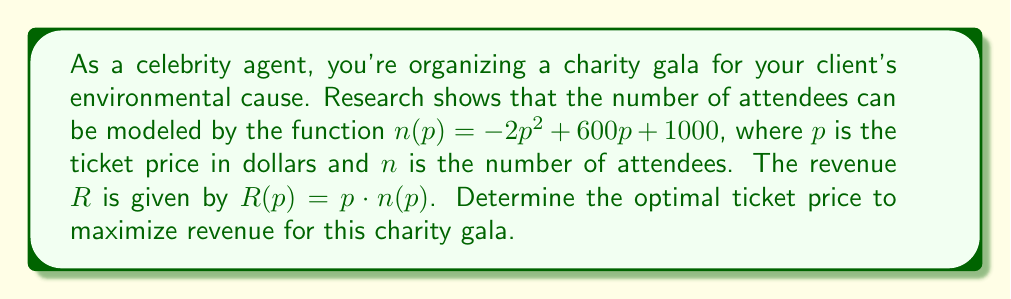Could you help me with this problem? To find the optimal ticket price, we need to follow these steps:

1) First, let's express the revenue function in terms of $p$:
   $R(p) = p \cdot n(p) = p(-2p^2 + 600p + 1000)$
   $R(p) = -2p^3 + 600p^2 + 1000p$

2) To find the maximum revenue, we need to find the critical points of this function. We do this by taking the derivative and setting it equal to zero:
   $R'(p) = -6p^2 + 1200p + 1000$
   $-6p^2 + 1200p + 1000 = 0$

3) This is a quadratic equation. We can solve it using the quadratic formula:
   $p = \frac{-b \pm \sqrt{b^2 - 4ac}}{2a}$

   Where $a = -6$, $b = 1200$, and $c = 1000$

4) Plugging in these values:
   $p = \frac{-1200 \pm \sqrt{1200^2 - 4(-6)(1000)}}{2(-6)}$
   $= \frac{-1200 \pm \sqrt{1440000 + 24000}}{-12}$
   $= \frac{-1200 \pm \sqrt{1464000}}{-12}$
   $= \frac{-1200 \pm 1210}{-12}$

5) This gives us two solutions:
   $p_1 = \frac{-1200 + 1210}{-12} = \frac{10}{-12} \approx -0.83$
   $p_2 = \frac{-1200 - 1210}{-12} = \frac{-2410}{-12} \approx 200.83$

6) Since price cannot be negative, we discard the negative solution. Therefore, the optimal price is approximately $200.83.

7) To confirm this is a maximum and not a minimum, we can check the second derivative:
   $R''(p) = -12p + 1200$
   At $p = 200.83$, $R''(200.83) \approx -1210 < 0$, confirming this is indeed a maximum.
Answer: The optimal ticket price to maximize revenue for the charity gala is approximately $200.83. 